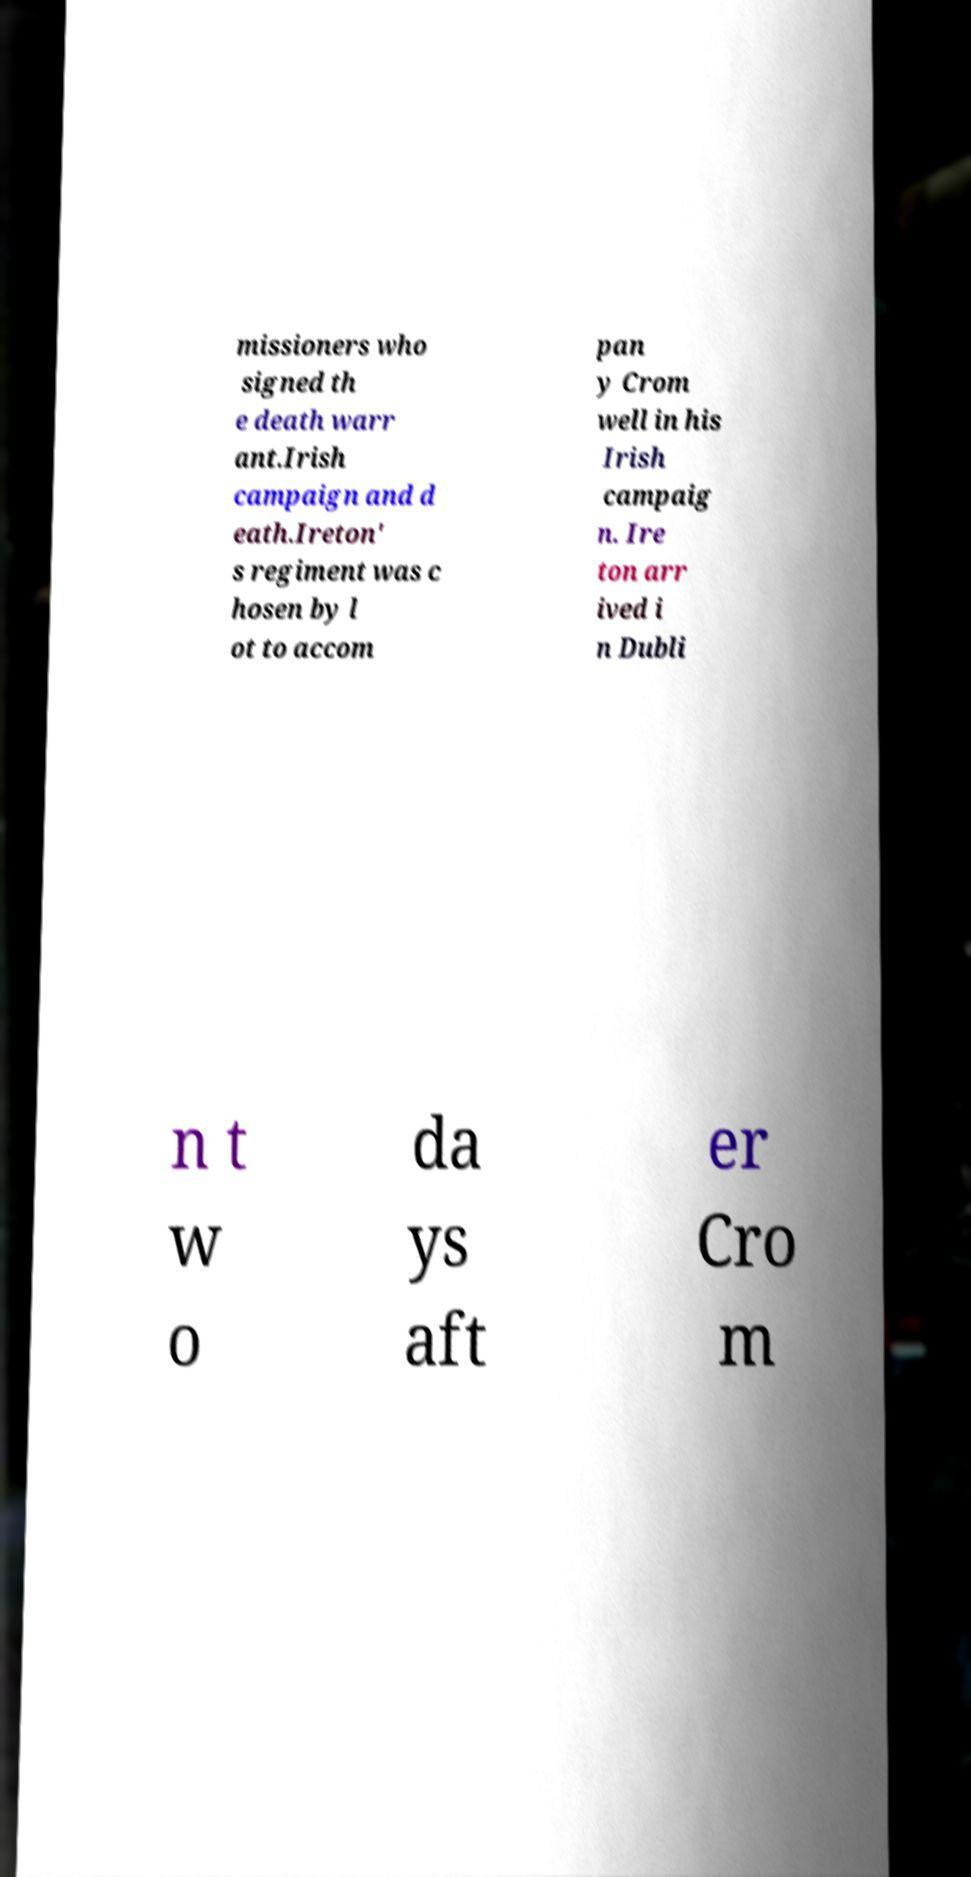Please read and relay the text visible in this image. What does it say? missioners who signed th e death warr ant.Irish campaign and d eath.Ireton' s regiment was c hosen by l ot to accom pan y Crom well in his Irish campaig n. Ire ton arr ived i n Dubli n t w o da ys aft er Cro m 